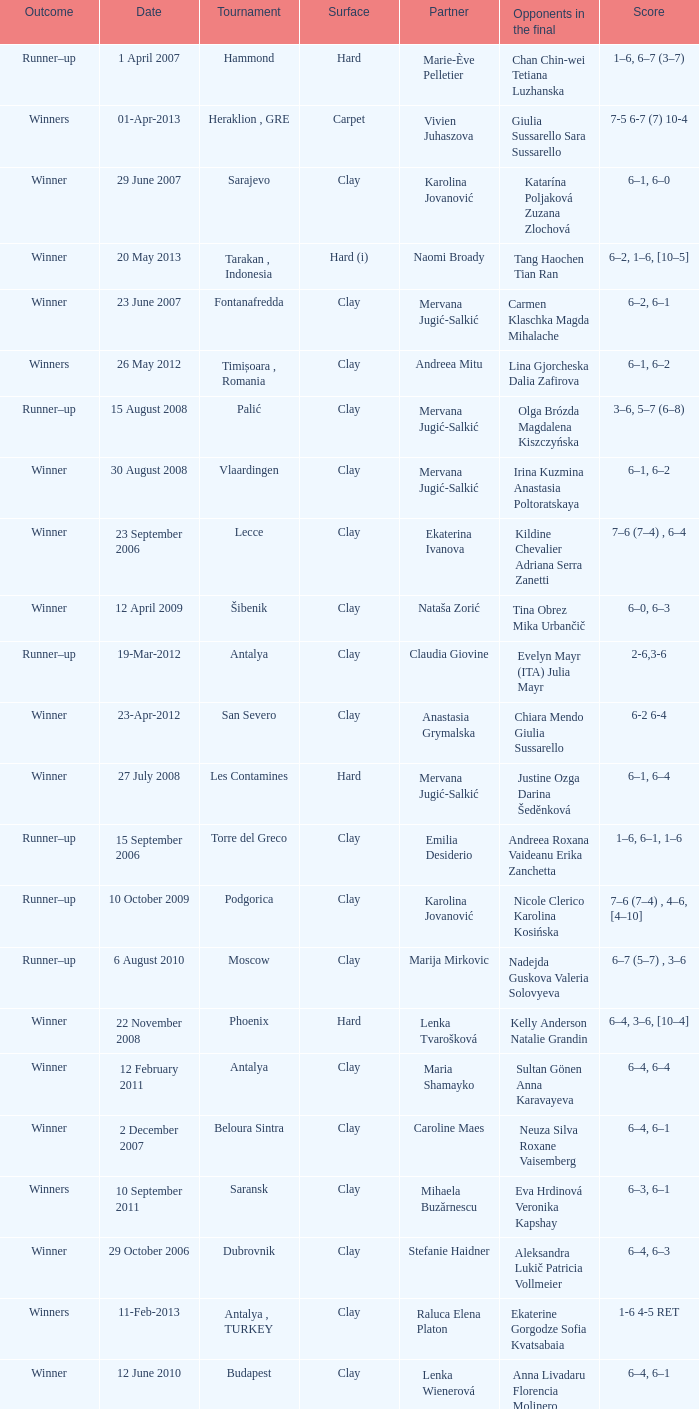Who were the opponents in the final at Noida? Kelly Anderson Chanelle Scheepers. 